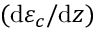Convert formula to latex. <formula><loc_0><loc_0><loc_500><loc_500>( d \varepsilon _ { c } / d z )</formula> 